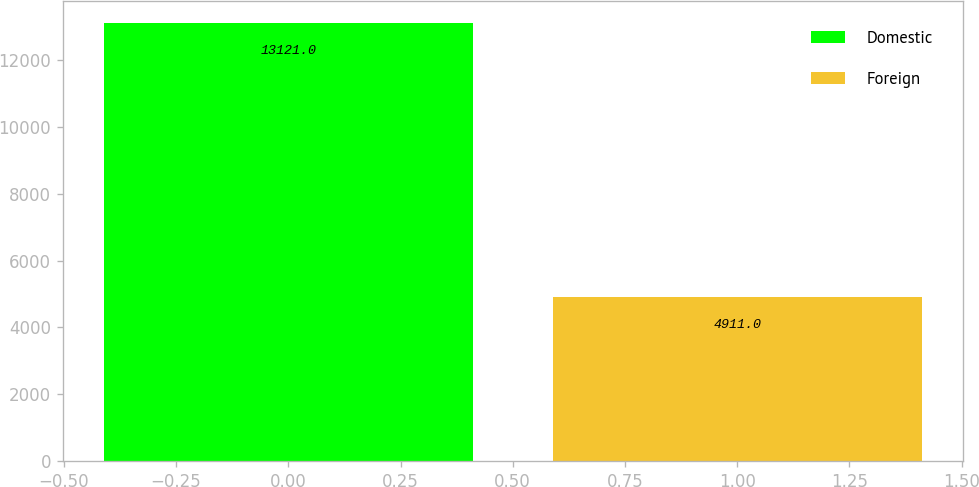<chart> <loc_0><loc_0><loc_500><loc_500><bar_chart><fcel>Domestic<fcel>Foreign<nl><fcel>13121<fcel>4911<nl></chart> 